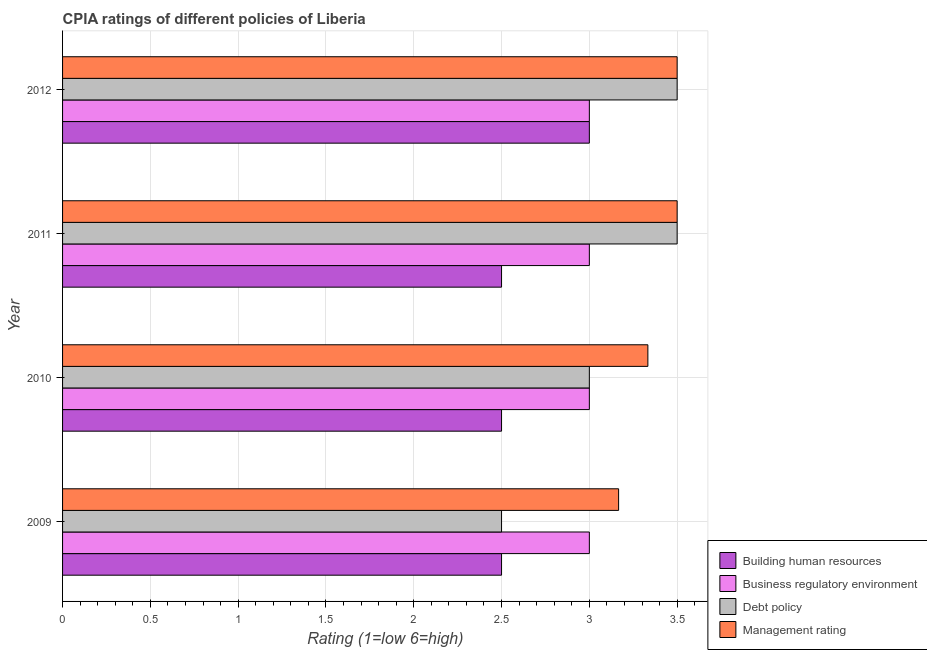How many different coloured bars are there?
Your response must be concise. 4. How many groups of bars are there?
Ensure brevity in your answer.  4. Are the number of bars per tick equal to the number of legend labels?
Your answer should be very brief. Yes. What is the cpia rating of management in 2009?
Your answer should be compact. 3.17. Across all years, what is the minimum cpia rating of building human resources?
Provide a short and direct response. 2.5. In which year was the cpia rating of management minimum?
Make the answer very short. 2009. What is the total cpia rating of business regulatory environment in the graph?
Give a very brief answer. 12. What is the difference between the cpia rating of management in 2009 and that in 2011?
Offer a very short reply. -0.33. What is the difference between the cpia rating of business regulatory environment in 2010 and the cpia rating of building human resources in 2011?
Offer a very short reply. 0.5. What is the average cpia rating of management per year?
Provide a short and direct response. 3.38. In the year 2010, what is the difference between the cpia rating of business regulatory environment and cpia rating of management?
Provide a succinct answer. -0.33. What is the ratio of the cpia rating of management in 2010 to that in 2011?
Make the answer very short. 0.95. Is the cpia rating of business regulatory environment in 2009 less than that in 2010?
Offer a terse response. No. Is the difference between the cpia rating of business regulatory environment in 2009 and 2010 greater than the difference between the cpia rating of debt policy in 2009 and 2010?
Ensure brevity in your answer.  Yes. What is the difference between the highest and the second highest cpia rating of business regulatory environment?
Provide a succinct answer. 0. Is the sum of the cpia rating of debt policy in 2010 and 2012 greater than the maximum cpia rating of business regulatory environment across all years?
Offer a very short reply. Yes. What does the 2nd bar from the top in 2009 represents?
Your response must be concise. Debt policy. What does the 1st bar from the bottom in 2011 represents?
Keep it short and to the point. Building human resources. Is it the case that in every year, the sum of the cpia rating of building human resources and cpia rating of business regulatory environment is greater than the cpia rating of debt policy?
Offer a very short reply. Yes. Are all the bars in the graph horizontal?
Offer a very short reply. Yes. Are the values on the major ticks of X-axis written in scientific E-notation?
Ensure brevity in your answer.  No. Does the graph contain any zero values?
Your answer should be compact. No. Does the graph contain grids?
Keep it short and to the point. Yes. Where does the legend appear in the graph?
Give a very brief answer. Bottom right. What is the title of the graph?
Offer a very short reply. CPIA ratings of different policies of Liberia. Does "Macroeconomic management" appear as one of the legend labels in the graph?
Provide a succinct answer. No. What is the Rating (1=low 6=high) in Management rating in 2009?
Your answer should be very brief. 3.17. What is the Rating (1=low 6=high) of Building human resources in 2010?
Your answer should be compact. 2.5. What is the Rating (1=low 6=high) of Management rating in 2010?
Ensure brevity in your answer.  3.33. What is the Rating (1=low 6=high) of Debt policy in 2011?
Ensure brevity in your answer.  3.5. What is the Rating (1=low 6=high) of Debt policy in 2012?
Your answer should be very brief. 3.5. What is the Rating (1=low 6=high) in Management rating in 2012?
Your response must be concise. 3.5. Across all years, what is the maximum Rating (1=low 6=high) in Building human resources?
Keep it short and to the point. 3. Across all years, what is the maximum Rating (1=low 6=high) of Business regulatory environment?
Provide a succinct answer. 3. Across all years, what is the maximum Rating (1=low 6=high) of Debt policy?
Keep it short and to the point. 3.5. Across all years, what is the maximum Rating (1=low 6=high) of Management rating?
Your answer should be compact. 3.5. Across all years, what is the minimum Rating (1=low 6=high) in Business regulatory environment?
Make the answer very short. 3. Across all years, what is the minimum Rating (1=low 6=high) in Debt policy?
Provide a short and direct response. 2.5. Across all years, what is the minimum Rating (1=low 6=high) in Management rating?
Provide a short and direct response. 3.17. What is the total Rating (1=low 6=high) in Building human resources in the graph?
Your answer should be very brief. 10.5. What is the total Rating (1=low 6=high) of Management rating in the graph?
Your answer should be very brief. 13.5. What is the difference between the Rating (1=low 6=high) in Building human resources in 2009 and that in 2010?
Make the answer very short. 0. What is the difference between the Rating (1=low 6=high) of Building human resources in 2009 and that in 2011?
Provide a short and direct response. 0. What is the difference between the Rating (1=low 6=high) in Management rating in 2009 and that in 2011?
Make the answer very short. -0.33. What is the difference between the Rating (1=low 6=high) of Building human resources in 2009 and that in 2012?
Keep it short and to the point. -0.5. What is the difference between the Rating (1=low 6=high) in Business regulatory environment in 2009 and that in 2012?
Offer a terse response. 0. What is the difference between the Rating (1=low 6=high) of Management rating in 2009 and that in 2012?
Give a very brief answer. -0.33. What is the difference between the Rating (1=low 6=high) in Building human resources in 2010 and that in 2011?
Keep it short and to the point. 0. What is the difference between the Rating (1=low 6=high) in Business regulatory environment in 2010 and that in 2011?
Provide a succinct answer. 0. What is the difference between the Rating (1=low 6=high) of Debt policy in 2010 and that in 2011?
Your answer should be very brief. -0.5. What is the difference between the Rating (1=low 6=high) in Management rating in 2010 and that in 2011?
Give a very brief answer. -0.17. What is the difference between the Rating (1=low 6=high) of Building human resources in 2010 and that in 2012?
Your answer should be very brief. -0.5. What is the difference between the Rating (1=low 6=high) of Management rating in 2010 and that in 2012?
Keep it short and to the point. -0.17. What is the difference between the Rating (1=low 6=high) in Management rating in 2011 and that in 2012?
Your response must be concise. 0. What is the difference between the Rating (1=low 6=high) in Building human resources in 2009 and the Rating (1=low 6=high) in Business regulatory environment in 2010?
Your answer should be compact. -0.5. What is the difference between the Rating (1=low 6=high) of Building human resources in 2009 and the Rating (1=low 6=high) of Debt policy in 2010?
Make the answer very short. -0.5. What is the difference between the Rating (1=low 6=high) in Building human resources in 2009 and the Rating (1=low 6=high) in Management rating in 2010?
Provide a succinct answer. -0.83. What is the difference between the Rating (1=low 6=high) of Business regulatory environment in 2009 and the Rating (1=low 6=high) of Debt policy in 2010?
Your answer should be compact. 0. What is the difference between the Rating (1=low 6=high) of Business regulatory environment in 2009 and the Rating (1=low 6=high) of Management rating in 2010?
Offer a very short reply. -0.33. What is the difference between the Rating (1=low 6=high) of Building human resources in 2009 and the Rating (1=low 6=high) of Business regulatory environment in 2011?
Your response must be concise. -0.5. What is the difference between the Rating (1=low 6=high) in Building human resources in 2009 and the Rating (1=low 6=high) in Debt policy in 2011?
Ensure brevity in your answer.  -1. What is the difference between the Rating (1=low 6=high) of Business regulatory environment in 2009 and the Rating (1=low 6=high) of Debt policy in 2011?
Keep it short and to the point. -0.5. What is the difference between the Rating (1=low 6=high) of Building human resources in 2009 and the Rating (1=low 6=high) of Debt policy in 2012?
Your response must be concise. -1. What is the difference between the Rating (1=low 6=high) of Building human resources in 2009 and the Rating (1=low 6=high) of Management rating in 2012?
Your answer should be compact. -1. What is the difference between the Rating (1=low 6=high) of Business regulatory environment in 2009 and the Rating (1=low 6=high) of Debt policy in 2012?
Offer a very short reply. -0.5. What is the difference between the Rating (1=low 6=high) of Debt policy in 2009 and the Rating (1=low 6=high) of Management rating in 2012?
Your response must be concise. -1. What is the difference between the Rating (1=low 6=high) in Building human resources in 2010 and the Rating (1=low 6=high) in Business regulatory environment in 2011?
Your response must be concise. -0.5. What is the difference between the Rating (1=low 6=high) of Building human resources in 2010 and the Rating (1=low 6=high) of Debt policy in 2011?
Make the answer very short. -1. What is the difference between the Rating (1=low 6=high) in Building human resources in 2010 and the Rating (1=low 6=high) in Management rating in 2011?
Offer a terse response. -1. What is the difference between the Rating (1=low 6=high) of Building human resources in 2010 and the Rating (1=low 6=high) of Business regulatory environment in 2012?
Ensure brevity in your answer.  -0.5. What is the difference between the Rating (1=low 6=high) in Business regulatory environment in 2010 and the Rating (1=low 6=high) in Management rating in 2012?
Provide a succinct answer. -0.5. What is the difference between the Rating (1=low 6=high) of Debt policy in 2010 and the Rating (1=low 6=high) of Management rating in 2012?
Offer a very short reply. -0.5. What is the difference between the Rating (1=low 6=high) of Building human resources in 2011 and the Rating (1=low 6=high) of Business regulatory environment in 2012?
Keep it short and to the point. -0.5. What is the difference between the Rating (1=low 6=high) of Building human resources in 2011 and the Rating (1=low 6=high) of Debt policy in 2012?
Your answer should be very brief. -1. What is the difference between the Rating (1=low 6=high) in Building human resources in 2011 and the Rating (1=low 6=high) in Management rating in 2012?
Provide a short and direct response. -1. What is the difference between the Rating (1=low 6=high) in Business regulatory environment in 2011 and the Rating (1=low 6=high) in Debt policy in 2012?
Ensure brevity in your answer.  -0.5. What is the difference between the Rating (1=low 6=high) of Debt policy in 2011 and the Rating (1=low 6=high) of Management rating in 2012?
Ensure brevity in your answer.  0. What is the average Rating (1=low 6=high) of Building human resources per year?
Your response must be concise. 2.62. What is the average Rating (1=low 6=high) of Business regulatory environment per year?
Keep it short and to the point. 3. What is the average Rating (1=low 6=high) of Debt policy per year?
Make the answer very short. 3.12. What is the average Rating (1=low 6=high) in Management rating per year?
Your answer should be compact. 3.38. In the year 2009, what is the difference between the Rating (1=low 6=high) in Building human resources and Rating (1=low 6=high) in Debt policy?
Provide a succinct answer. 0. In the year 2009, what is the difference between the Rating (1=low 6=high) in Building human resources and Rating (1=low 6=high) in Management rating?
Offer a terse response. -0.67. In the year 2009, what is the difference between the Rating (1=low 6=high) of Business regulatory environment and Rating (1=low 6=high) of Management rating?
Provide a succinct answer. -0.17. In the year 2009, what is the difference between the Rating (1=low 6=high) in Debt policy and Rating (1=low 6=high) in Management rating?
Provide a short and direct response. -0.67. In the year 2010, what is the difference between the Rating (1=low 6=high) in Building human resources and Rating (1=low 6=high) in Debt policy?
Ensure brevity in your answer.  -0.5. In the year 2010, what is the difference between the Rating (1=low 6=high) in Building human resources and Rating (1=low 6=high) in Management rating?
Provide a succinct answer. -0.83. In the year 2010, what is the difference between the Rating (1=low 6=high) of Business regulatory environment and Rating (1=low 6=high) of Debt policy?
Provide a succinct answer. 0. In the year 2010, what is the difference between the Rating (1=low 6=high) of Business regulatory environment and Rating (1=low 6=high) of Management rating?
Your response must be concise. -0.33. In the year 2011, what is the difference between the Rating (1=low 6=high) in Building human resources and Rating (1=low 6=high) in Management rating?
Your answer should be compact. -1. In the year 2011, what is the difference between the Rating (1=low 6=high) of Debt policy and Rating (1=low 6=high) of Management rating?
Keep it short and to the point. 0. In the year 2012, what is the difference between the Rating (1=low 6=high) in Building human resources and Rating (1=low 6=high) in Business regulatory environment?
Give a very brief answer. 0. In the year 2012, what is the difference between the Rating (1=low 6=high) in Building human resources and Rating (1=low 6=high) in Management rating?
Make the answer very short. -0.5. In the year 2012, what is the difference between the Rating (1=low 6=high) of Business regulatory environment and Rating (1=low 6=high) of Debt policy?
Your answer should be compact. -0.5. In the year 2012, what is the difference between the Rating (1=low 6=high) of Business regulatory environment and Rating (1=low 6=high) of Management rating?
Ensure brevity in your answer.  -0.5. What is the ratio of the Rating (1=low 6=high) in Building human resources in 2009 to that in 2010?
Your answer should be very brief. 1. What is the ratio of the Rating (1=low 6=high) in Building human resources in 2009 to that in 2011?
Your response must be concise. 1. What is the ratio of the Rating (1=low 6=high) of Debt policy in 2009 to that in 2011?
Provide a short and direct response. 0.71. What is the ratio of the Rating (1=low 6=high) in Management rating in 2009 to that in 2011?
Give a very brief answer. 0.9. What is the ratio of the Rating (1=low 6=high) of Building human resources in 2009 to that in 2012?
Your answer should be compact. 0.83. What is the ratio of the Rating (1=low 6=high) of Management rating in 2009 to that in 2012?
Provide a short and direct response. 0.9. What is the ratio of the Rating (1=low 6=high) in Business regulatory environment in 2011 to that in 2012?
Offer a very short reply. 1. What is the difference between the highest and the second highest Rating (1=low 6=high) of Building human resources?
Provide a succinct answer. 0.5. What is the difference between the highest and the second highest Rating (1=low 6=high) of Debt policy?
Your response must be concise. 0. What is the difference between the highest and the lowest Rating (1=low 6=high) of Business regulatory environment?
Make the answer very short. 0. What is the difference between the highest and the lowest Rating (1=low 6=high) of Management rating?
Provide a succinct answer. 0.33. 